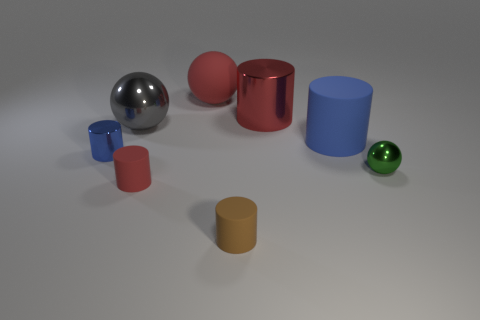Are there any gray metallic things that have the same shape as the big blue rubber thing?
Provide a succinct answer. No. There is a green sphere that is the same size as the brown object; what material is it?
Provide a short and direct response. Metal. What is the size of the shiny cylinder that is on the left side of the large gray ball?
Provide a succinct answer. Small. Is the size of the red cylinder that is in front of the small metal cylinder the same as the red rubber object that is behind the big gray metal sphere?
Keep it short and to the point. No. What number of big cylinders are made of the same material as the small red cylinder?
Your answer should be compact. 1. The big rubber cylinder has what color?
Offer a terse response. Blue. Are there any small brown cylinders in front of the brown matte thing?
Give a very brief answer. No. Is the color of the tiny ball the same as the large metallic sphere?
Your response must be concise. No. How many other cylinders have the same color as the large matte cylinder?
Provide a short and direct response. 1. What is the size of the shiny cylinder that is behind the shiny object on the left side of the big metal sphere?
Ensure brevity in your answer.  Large. 